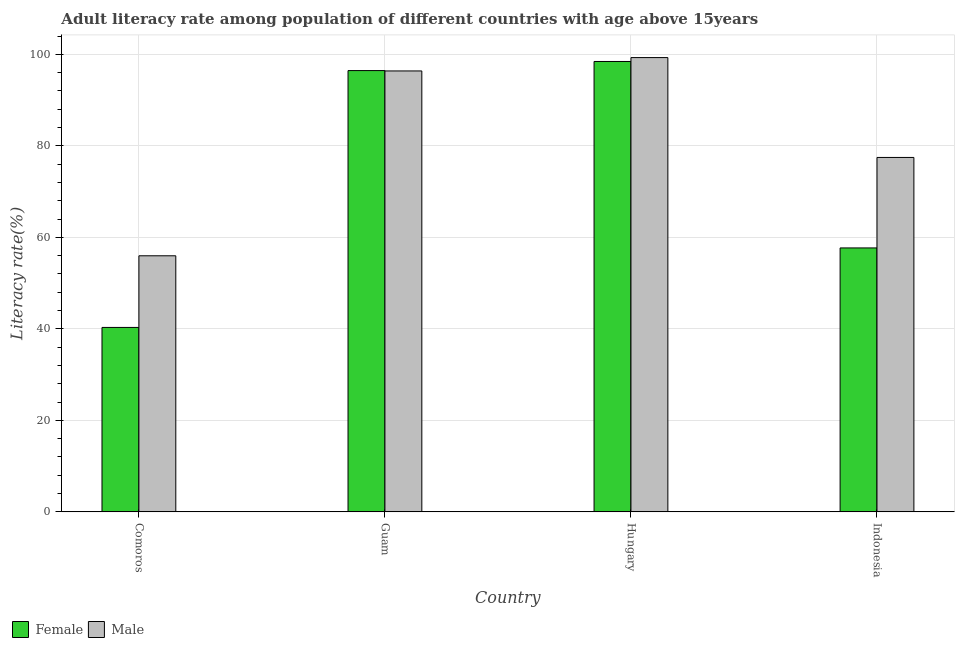How many different coloured bars are there?
Provide a short and direct response. 2. How many groups of bars are there?
Offer a terse response. 4. What is the label of the 1st group of bars from the left?
Your answer should be very brief. Comoros. In how many cases, is the number of bars for a given country not equal to the number of legend labels?
Provide a short and direct response. 0. What is the male adult literacy rate in Hungary?
Your response must be concise. 99.3. Across all countries, what is the maximum female adult literacy rate?
Offer a very short reply. 98.45. Across all countries, what is the minimum female adult literacy rate?
Your answer should be compact. 40.32. In which country was the female adult literacy rate maximum?
Your response must be concise. Hungary. In which country was the male adult literacy rate minimum?
Provide a short and direct response. Comoros. What is the total female adult literacy rate in the graph?
Provide a short and direct response. 292.93. What is the difference between the female adult literacy rate in Hungary and that in Indonesia?
Your answer should be compact. 40.76. What is the difference between the male adult literacy rate in Comoros and the female adult literacy rate in Hungary?
Provide a succinct answer. -42.48. What is the average male adult literacy rate per country?
Ensure brevity in your answer.  82.28. What is the difference between the male adult literacy rate and female adult literacy rate in Comoros?
Make the answer very short. 15.66. What is the ratio of the male adult literacy rate in Comoros to that in Hungary?
Ensure brevity in your answer.  0.56. Is the difference between the male adult literacy rate in Guam and Hungary greater than the difference between the female adult literacy rate in Guam and Hungary?
Keep it short and to the point. No. What is the difference between the highest and the second highest female adult literacy rate?
Offer a terse response. 1.99. What is the difference between the highest and the lowest male adult literacy rate?
Provide a succinct answer. 43.33. Is the sum of the female adult literacy rate in Hungary and Indonesia greater than the maximum male adult literacy rate across all countries?
Offer a very short reply. Yes. How many countries are there in the graph?
Offer a terse response. 4. What is the difference between two consecutive major ticks on the Y-axis?
Your answer should be very brief. 20. Does the graph contain grids?
Provide a short and direct response. Yes. How are the legend labels stacked?
Offer a terse response. Horizontal. What is the title of the graph?
Your answer should be very brief. Adult literacy rate among population of different countries with age above 15years. Does "Exports" appear as one of the legend labels in the graph?
Make the answer very short. No. What is the label or title of the Y-axis?
Your answer should be very brief. Literacy rate(%). What is the Literacy rate(%) in Female in Comoros?
Provide a short and direct response. 40.32. What is the Literacy rate(%) in Male in Comoros?
Your answer should be compact. 55.98. What is the Literacy rate(%) of Female in Guam?
Your response must be concise. 96.46. What is the Literacy rate(%) in Male in Guam?
Give a very brief answer. 96.38. What is the Literacy rate(%) of Female in Hungary?
Your answer should be compact. 98.45. What is the Literacy rate(%) of Male in Hungary?
Ensure brevity in your answer.  99.3. What is the Literacy rate(%) of Female in Indonesia?
Offer a very short reply. 57.69. What is the Literacy rate(%) in Male in Indonesia?
Keep it short and to the point. 77.47. Across all countries, what is the maximum Literacy rate(%) of Female?
Your response must be concise. 98.45. Across all countries, what is the maximum Literacy rate(%) of Male?
Provide a short and direct response. 99.3. Across all countries, what is the minimum Literacy rate(%) of Female?
Give a very brief answer. 40.32. Across all countries, what is the minimum Literacy rate(%) of Male?
Offer a terse response. 55.98. What is the total Literacy rate(%) of Female in the graph?
Ensure brevity in your answer.  292.93. What is the total Literacy rate(%) of Male in the graph?
Ensure brevity in your answer.  329.14. What is the difference between the Literacy rate(%) of Female in Comoros and that in Guam?
Ensure brevity in your answer.  -56.15. What is the difference between the Literacy rate(%) in Male in Comoros and that in Guam?
Ensure brevity in your answer.  -40.41. What is the difference between the Literacy rate(%) of Female in Comoros and that in Hungary?
Offer a terse response. -58.14. What is the difference between the Literacy rate(%) of Male in Comoros and that in Hungary?
Ensure brevity in your answer.  -43.33. What is the difference between the Literacy rate(%) in Female in Comoros and that in Indonesia?
Offer a terse response. -17.38. What is the difference between the Literacy rate(%) of Male in Comoros and that in Indonesia?
Keep it short and to the point. -21.5. What is the difference between the Literacy rate(%) of Female in Guam and that in Hungary?
Keep it short and to the point. -1.99. What is the difference between the Literacy rate(%) of Male in Guam and that in Hungary?
Ensure brevity in your answer.  -2.92. What is the difference between the Literacy rate(%) of Female in Guam and that in Indonesia?
Keep it short and to the point. 38.77. What is the difference between the Literacy rate(%) of Male in Guam and that in Indonesia?
Your answer should be very brief. 18.91. What is the difference between the Literacy rate(%) of Female in Hungary and that in Indonesia?
Your answer should be very brief. 40.76. What is the difference between the Literacy rate(%) in Male in Hungary and that in Indonesia?
Keep it short and to the point. 21.83. What is the difference between the Literacy rate(%) in Female in Comoros and the Literacy rate(%) in Male in Guam?
Offer a terse response. -56.06. What is the difference between the Literacy rate(%) in Female in Comoros and the Literacy rate(%) in Male in Hungary?
Keep it short and to the point. -58.99. What is the difference between the Literacy rate(%) of Female in Comoros and the Literacy rate(%) of Male in Indonesia?
Keep it short and to the point. -37.16. What is the difference between the Literacy rate(%) in Female in Guam and the Literacy rate(%) in Male in Hungary?
Keep it short and to the point. -2.84. What is the difference between the Literacy rate(%) in Female in Guam and the Literacy rate(%) in Male in Indonesia?
Make the answer very short. 18.99. What is the difference between the Literacy rate(%) in Female in Hungary and the Literacy rate(%) in Male in Indonesia?
Offer a very short reply. 20.98. What is the average Literacy rate(%) of Female per country?
Offer a terse response. 73.23. What is the average Literacy rate(%) of Male per country?
Offer a terse response. 82.28. What is the difference between the Literacy rate(%) of Female and Literacy rate(%) of Male in Comoros?
Offer a terse response. -15.66. What is the difference between the Literacy rate(%) of Female and Literacy rate(%) of Male in Guam?
Offer a very short reply. 0.08. What is the difference between the Literacy rate(%) of Female and Literacy rate(%) of Male in Hungary?
Keep it short and to the point. -0.85. What is the difference between the Literacy rate(%) of Female and Literacy rate(%) of Male in Indonesia?
Ensure brevity in your answer.  -19.78. What is the ratio of the Literacy rate(%) of Female in Comoros to that in Guam?
Your answer should be very brief. 0.42. What is the ratio of the Literacy rate(%) in Male in Comoros to that in Guam?
Your response must be concise. 0.58. What is the ratio of the Literacy rate(%) of Female in Comoros to that in Hungary?
Offer a terse response. 0.41. What is the ratio of the Literacy rate(%) in Male in Comoros to that in Hungary?
Offer a very short reply. 0.56. What is the ratio of the Literacy rate(%) of Female in Comoros to that in Indonesia?
Keep it short and to the point. 0.7. What is the ratio of the Literacy rate(%) in Male in Comoros to that in Indonesia?
Your answer should be very brief. 0.72. What is the ratio of the Literacy rate(%) in Female in Guam to that in Hungary?
Ensure brevity in your answer.  0.98. What is the ratio of the Literacy rate(%) in Male in Guam to that in Hungary?
Offer a very short reply. 0.97. What is the ratio of the Literacy rate(%) of Female in Guam to that in Indonesia?
Keep it short and to the point. 1.67. What is the ratio of the Literacy rate(%) in Male in Guam to that in Indonesia?
Your answer should be very brief. 1.24. What is the ratio of the Literacy rate(%) in Female in Hungary to that in Indonesia?
Make the answer very short. 1.71. What is the ratio of the Literacy rate(%) of Male in Hungary to that in Indonesia?
Offer a terse response. 1.28. What is the difference between the highest and the second highest Literacy rate(%) in Female?
Your answer should be very brief. 1.99. What is the difference between the highest and the second highest Literacy rate(%) of Male?
Your response must be concise. 2.92. What is the difference between the highest and the lowest Literacy rate(%) of Female?
Make the answer very short. 58.14. What is the difference between the highest and the lowest Literacy rate(%) of Male?
Offer a very short reply. 43.33. 